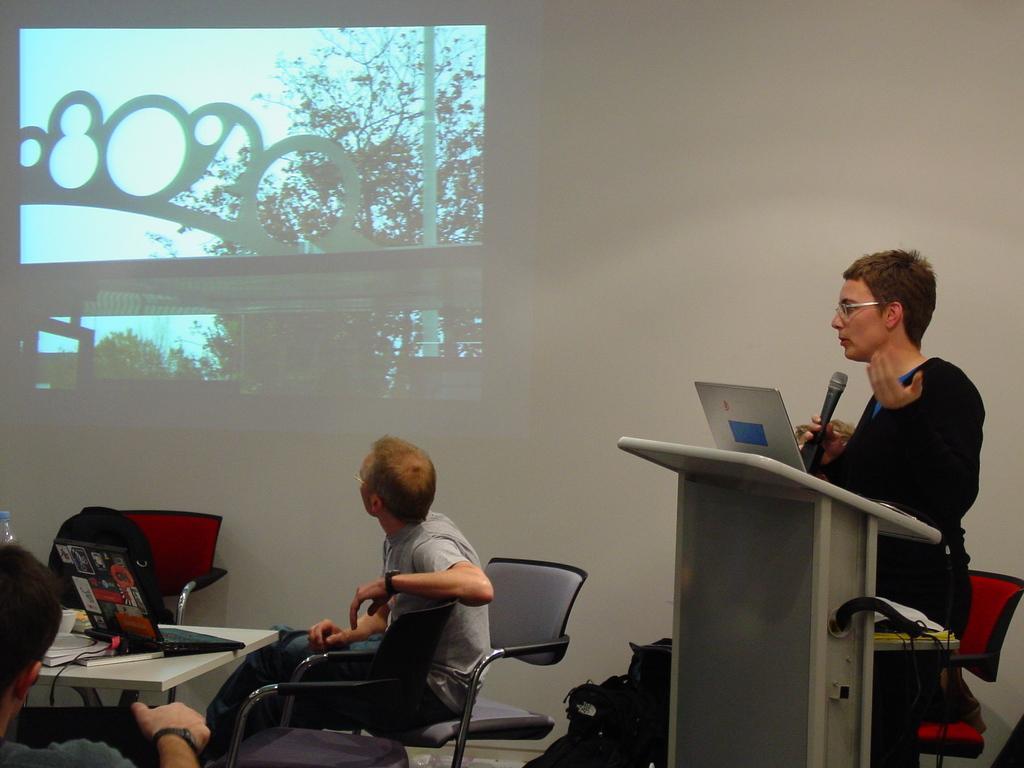How would you summarize this image in a sentence or two? It seems to be the image is inside the room. In the image on right side there is a person standing in front of podium and the person is also a holding a microphone. On podium we can see a laptop, on left side there are two people sitting on chair on table we can see a bag,laptop,book and a water bottle. In background we can see a screen,trees and sky is on top. 